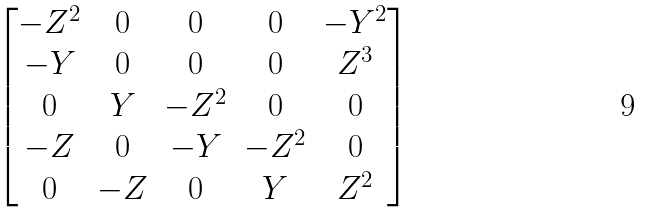<formula> <loc_0><loc_0><loc_500><loc_500>\begin{bmatrix} - Z ^ { 2 } & 0 & 0 & 0 & - Y ^ { 2 } \\ - Y & 0 & 0 & 0 & Z ^ { 3 } \\ 0 & Y & - Z ^ { 2 } & 0 & 0 \\ - Z & 0 & - Y & - Z ^ { 2 } & 0 \\ 0 & - Z & 0 & Y & Z ^ { 2 } \\ \end{bmatrix}</formula> 